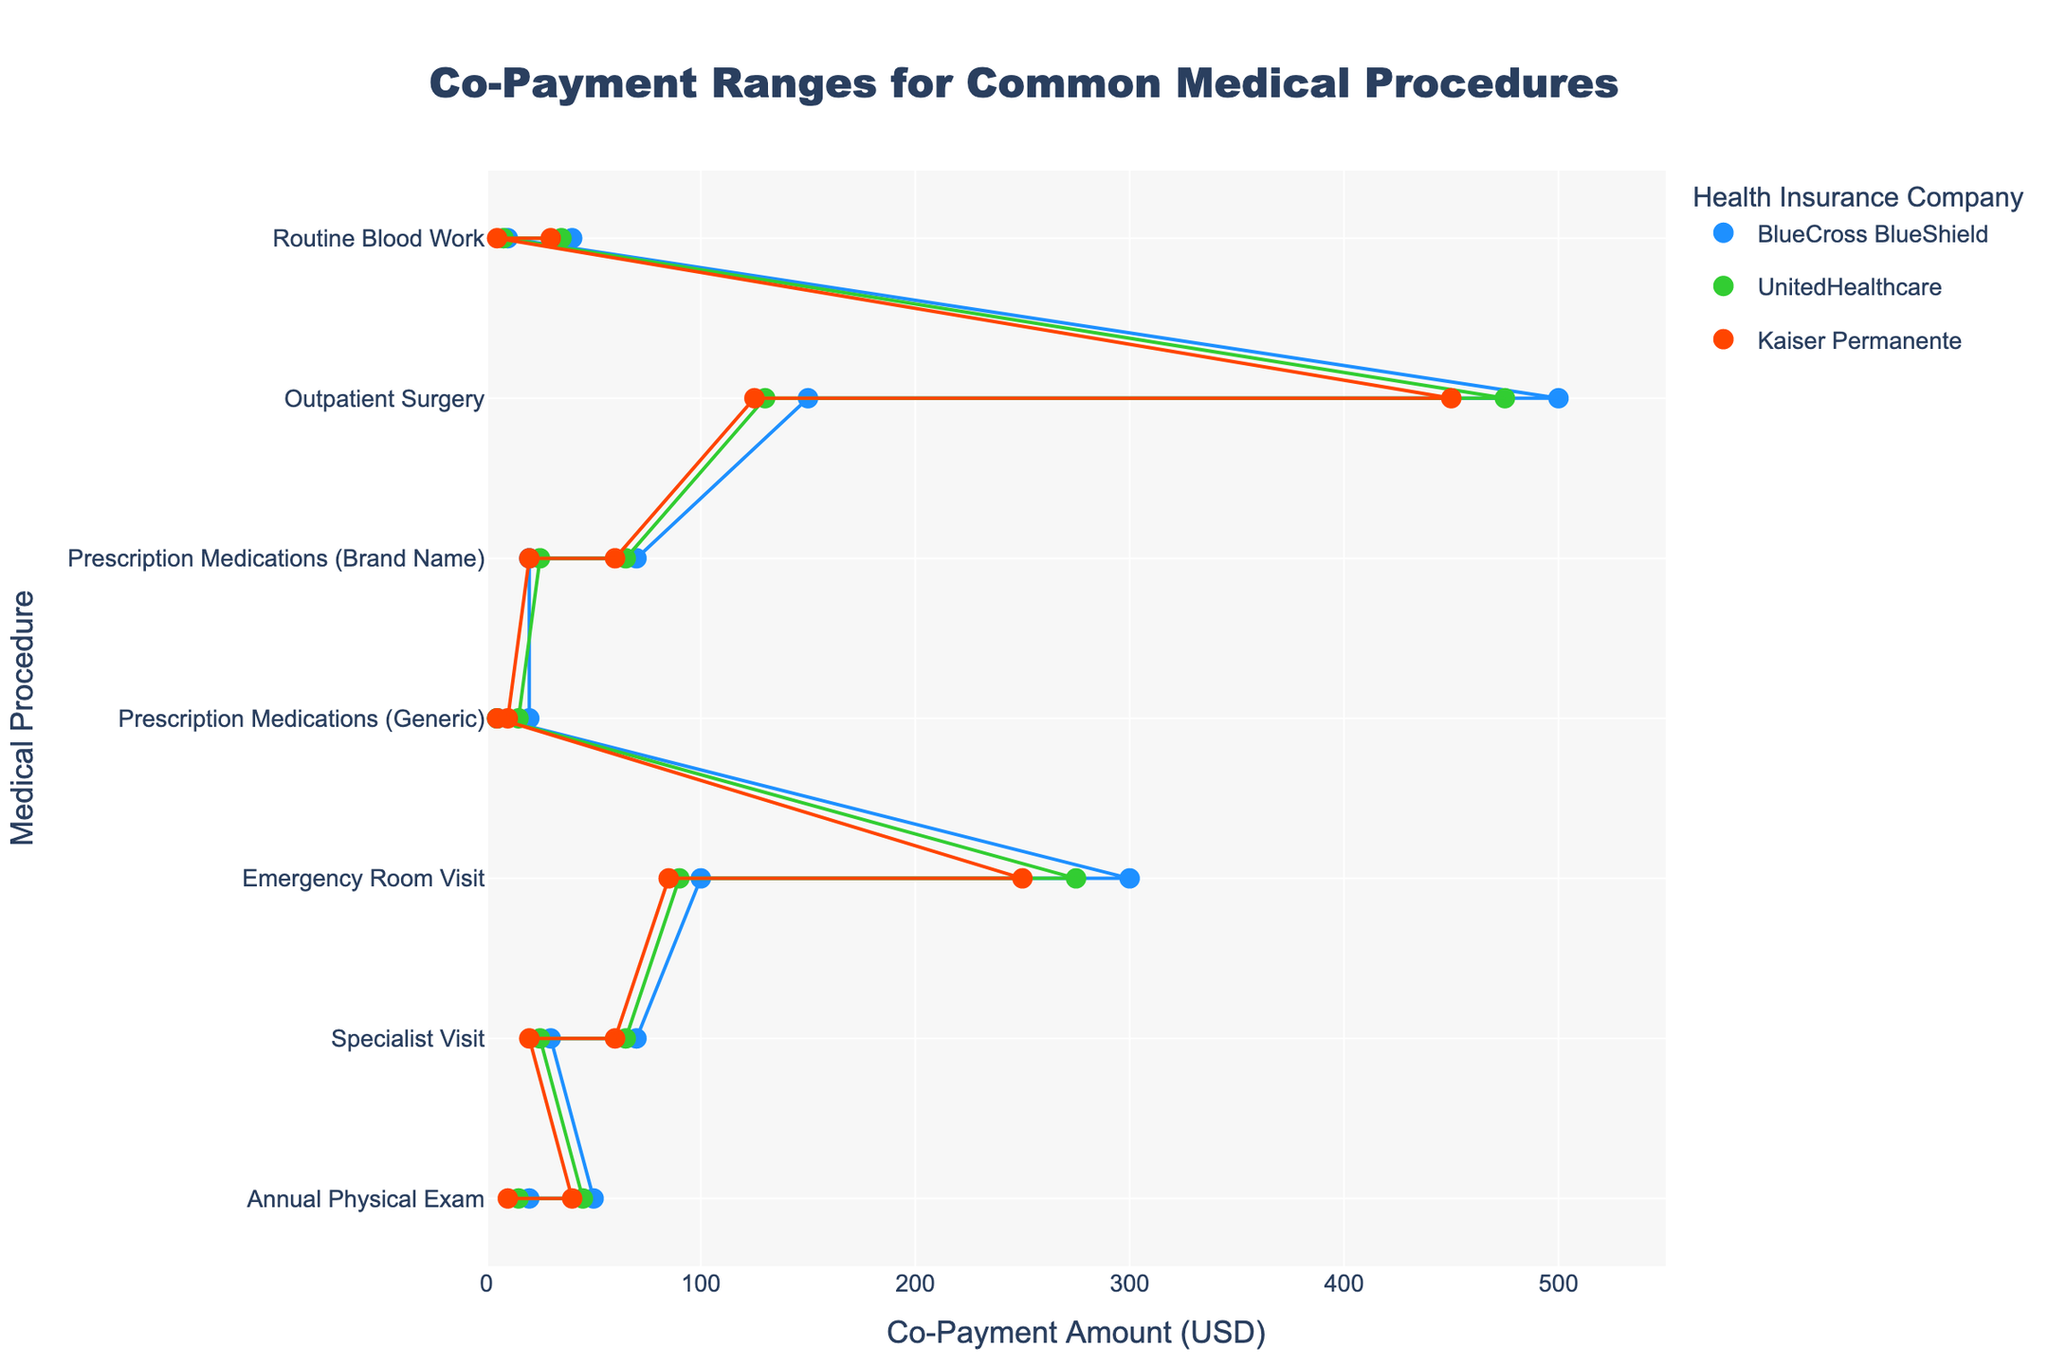What's the range of co-payment costs for an Annual Physical Exam under BlueCross BlueShield? Locate the dots and line corresponding to "Annual Physical Exam" for BlueCross BlueShield and check the range indicated by the markers and connecting line.
Answer: 20-50 Which health insurance company offers the lowest minimum co-payment for Prescription Medications (Generic)? Look at the minimum values of the co-payment range for Prescription Medications (Generic) across all companies and identify the one with the lowest value.
Answer: Kaiser Permanente How much higher is the maximum co-payment for an Emergency Room Visit under BlueCross BlueShield compared to Kaiser Permanente? Compare the maximum co-payment values for an Emergency Room Visit between BlueCross BlueShield (300 USD) and Kaiser Permanente (250 USD) and calculate the difference.
Answer: 50 USD Which medical procedure has the highest maximum co-payment range under UnitedHealthcare? Examine the maximum co-payment values for all medical procedures under UnitedHealthcare and identify the one with the highest value.
Answer: Outpatient Surgery What is the average maximum co-payment for Specialist Visits among all three health insurance companies? Add the maximum co-payment values for Specialist Visits from BlueCross BlueShield (70 USD), UnitedHealthcare (65 USD), and Kaiser Permanente (60 USD), and divide by the number of companies (3) to find the average.
Answer: 65 USD Is the minimum co-payment for Routine Blood Work under Kaiser Permanente higher than the minimum co-payment for Prescription Medications (Brand Name) under UnitedHealthcare? Compare the minimum values of Routine Blood Work under Kaiser Permanente (5 USD) and Prescription Medications (Brand Name) under UnitedHealthcare (25 USD).
Answer: No Which medical procedure shows the biggest difference between minimum and maximum co-payment under BlueCross BlueShield? For BlueCross BlueShield, subtract the minimum co-payment from the maximum co-payment for each procedure and identify the one with the largest difference.
Answer: Outpatient Surgery Does Kaiser Permanente consistently have a lower minimum co-payment range across all procedures than BlueCross BlueShield? Compare the minimum co-payment values for each procedure for both companies to determine if Kaiser Permanente always has a lower minimum value compared to BlueCross BlueShield.
Answer: Yes Which health insurance company provides the most consistent (smallest range) co-payment cost for Prescription Medications (Generic)? Compare the range (max - min) of co-payment costs for Prescription Medications (Generic) across all three companies and identify the smallest range.
Answer: Kaiser Permanente Is there a procedure where UnitedHealthcare has both the lowest minimum and highest maximum co-payment when comparing with other companies? Check each procedure to see if UnitedHealthcare has both the lowest minimum and the highest maximum co-payment compared to the other companies.
Answer: No 